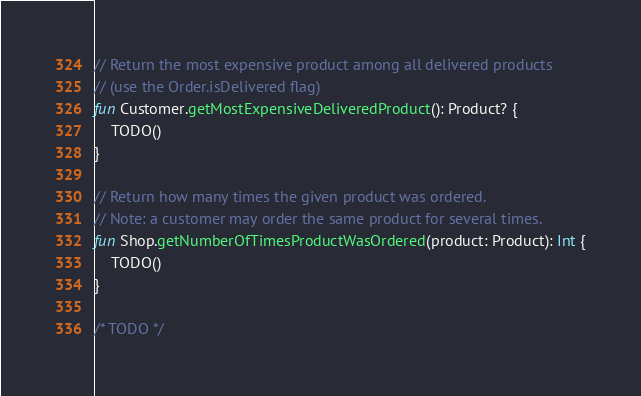Convert code to text. <code><loc_0><loc_0><loc_500><loc_500><_Kotlin_>// Return the most expensive product among all delivered products
// (use the Order.isDelivered flag)
fun Customer.getMostExpensiveDeliveredProduct(): Product? {
    TODO()
}

// Return how many times the given product was ordered.
// Note: a customer may order the same product for several times.
fun Shop.getNumberOfTimesProductWasOrdered(product: Product): Int {
    TODO()
}

/* TODO */
</code> 